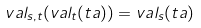<formula> <loc_0><loc_0><loc_500><loc_500>v a l _ { s , t } ( v a l _ { t } ( t a ) ) = v a l _ { s } ( t a )</formula> 